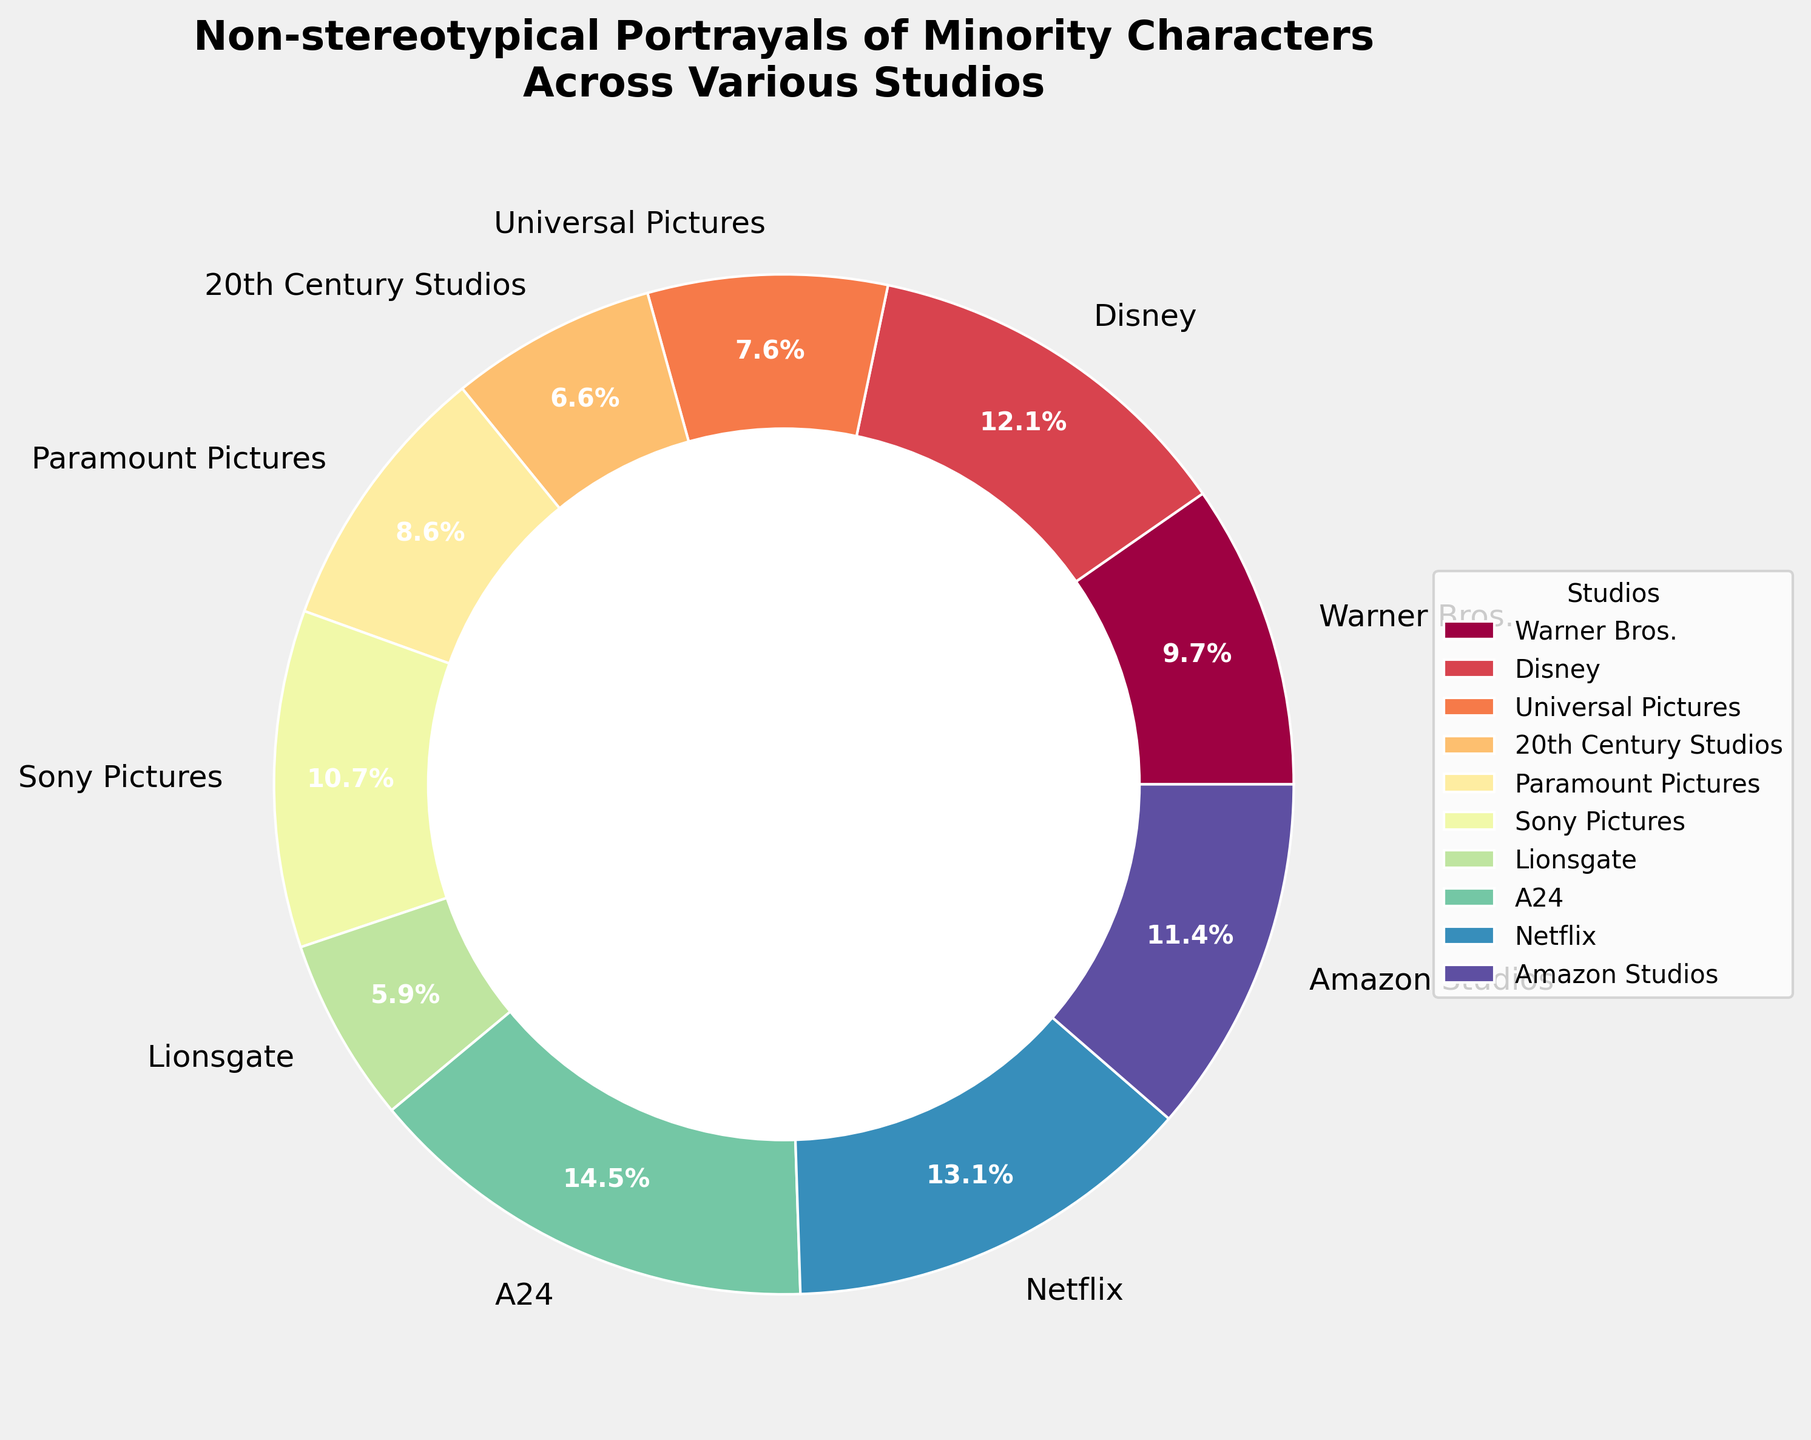What's the studio with the highest percentage of films with non-stereotypical portrayals of minority characters? To determine this, look for the largest section of the pie chart. The label and percentage for this section should indicate the studio with the highest percentage.
Answer: A24 Which studio films fall within the 30-40% range for non-stereotypical portrayals of minority characters? Identify the sections labeled with percentages between 30% and 40%. These sections' labels will provide the studios in this range.
Answer: Sony Pictures, Netflix, Amazon Studios What is the combined percentage of non-stereotypical portrayals for Warner Bros., Universal Pictures, and Paramount Pictures? Locate each studio's section and sum their percentages: Warner Bros. (28%), Universal Pictures (22%), and Paramount Pictures (25%). The combined percentage is 28 + 22 + 25.
Answer: 75% How does Disney compare to Amazon Studios in terms of the percentage of films with non-stereotypical portrayals? Identify the sections for Disney and Amazon Studios. Disney's percentage is 35%, while Amazon Studios' is 33%. Compare these numbers.
Answer: Disney has a slightly higher percentage than Amazon Studios Which studios have less than 20% of films with non-stereotypical portrayals of minority characters? Locate the sections with percentages below 20%. The studios with these percentages are the ones you are looking for.
Answer: 20th Century Studios, Lionsgate What is the average percentage of non-stereotypical portrayals for Disney, Sony Pictures, and Netflix? Find each studio's section and note their percentages: Disney (35%), Sony Pictures (31%), and Netflix (38%). Calculate the average: (35 + 31 + 38) / 3.
Answer: 34.7% Which studio is closest to having one-fourth (25%) of its films with non-stereotypical portrayals? Identify the sections with percentages near 25%. Check percentages on either side of 25% precisely.
Answer: Paramount Pictures (25%) How does A24's percentage compare to Lionsgate's? Look at the sections for A24 and Lionsgate. Note that A24’s percentage is 42% while Lionsgate's is 17%. Compare these values.
Answer: A24 has a much higher percentage than Lionsgate What is the percentage difference between Disney and Warner Bros.? Identify the sections of Disney (35%) and Warner Bros. (28%). Calculate the difference: 35 - 28.
Answer: 7% What color represents Netflix’s percentage in the pie chart? Look at the color used for the section labeled Netflix on the pie chart. Note the visual color representation.
Answer: The specific color needs to be visually identified directly from the plot (depends on the color palette used) 